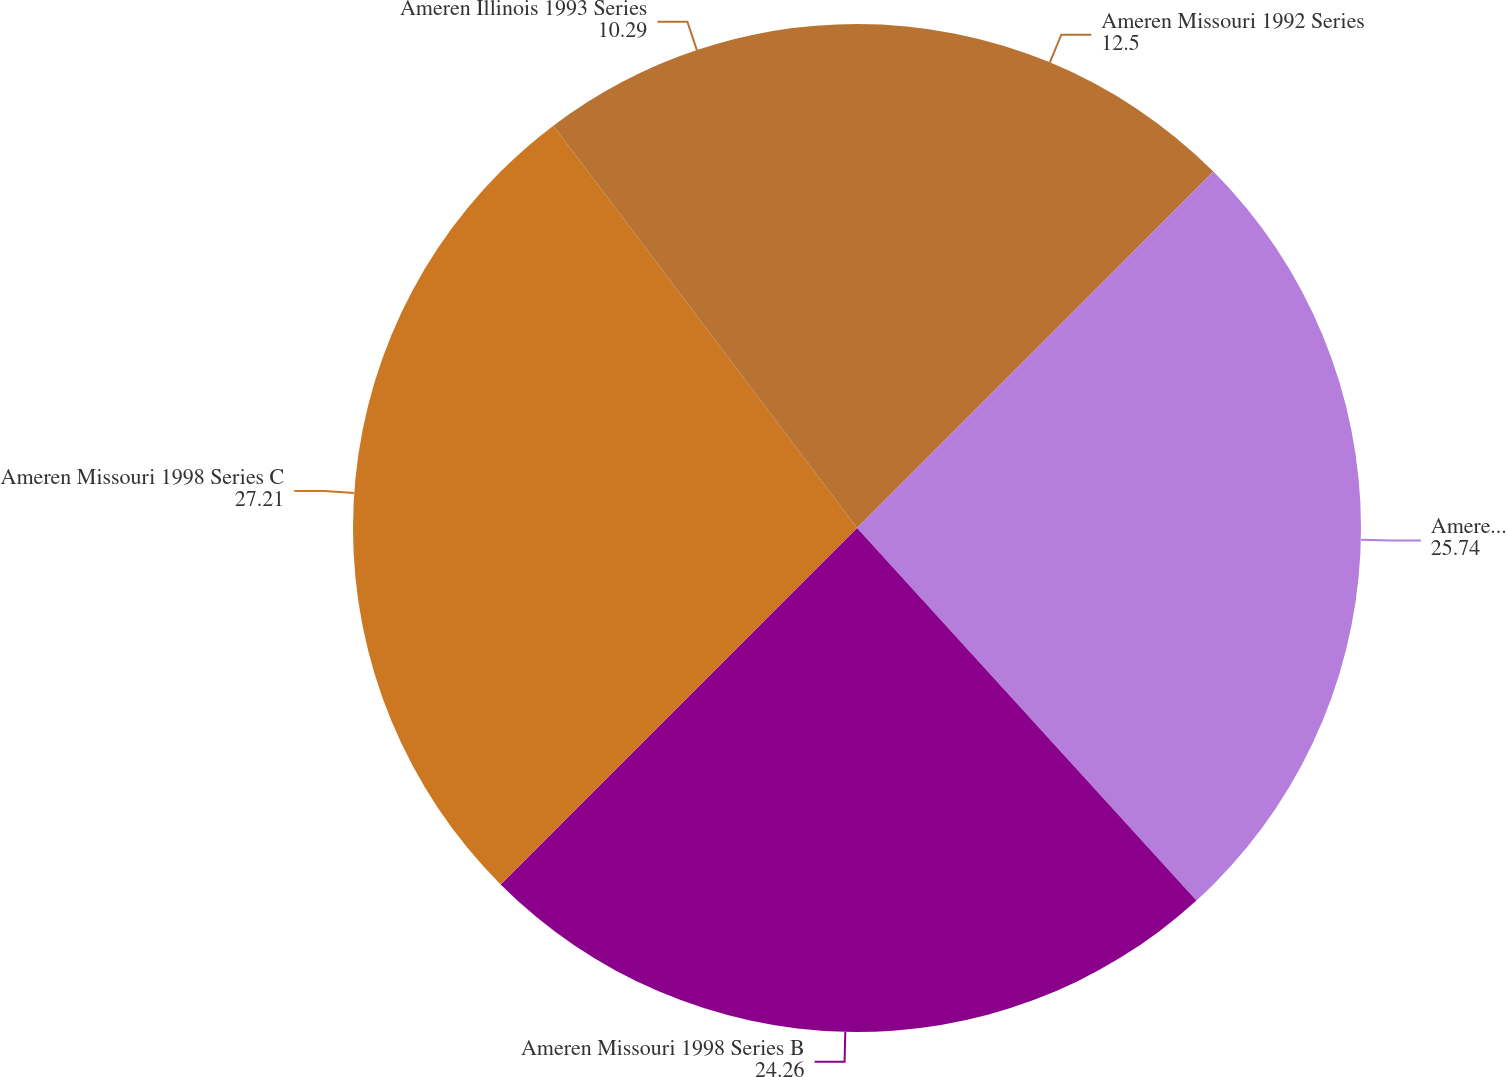<chart> <loc_0><loc_0><loc_500><loc_500><pie_chart><fcel>Ameren Missouri 1992 Series<fcel>Ameren Missouri 1998 Series A<fcel>Ameren Missouri 1998 Series B<fcel>Ameren Missouri 1998 Series C<fcel>Ameren Illinois 1993 Series<nl><fcel>12.5%<fcel>25.74%<fcel>24.26%<fcel>27.21%<fcel>10.29%<nl></chart> 